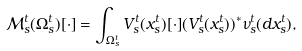<formula> <loc_0><loc_0><loc_500><loc_500>\mathcal { M } _ { s } ^ { t } ( \Omega _ { s } ^ { t } ) [ \cdot ] = \int _ { \Omega _ { s } ^ { t } } V _ { s } ^ { t } ( x _ { s } ^ { t } ) [ \cdot ] ( V _ { s } ^ { t } ( x _ { s } ^ { t } ) ) ^ { \ast } \nu _ { s } ^ { t } ( d x _ { s } ^ { t } ) ,</formula> 